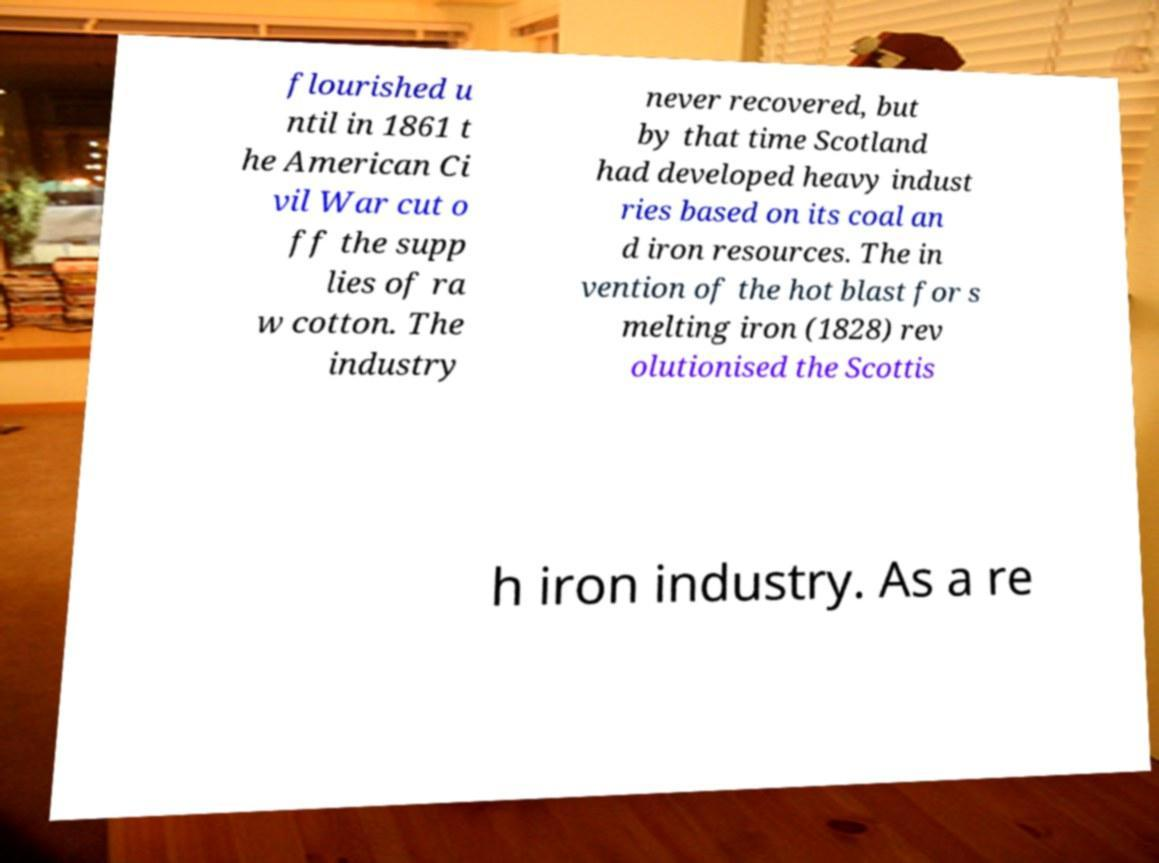For documentation purposes, I need the text within this image transcribed. Could you provide that? flourished u ntil in 1861 t he American Ci vil War cut o ff the supp lies of ra w cotton. The industry never recovered, but by that time Scotland had developed heavy indust ries based on its coal an d iron resources. The in vention of the hot blast for s melting iron (1828) rev olutionised the Scottis h iron industry. As a re 